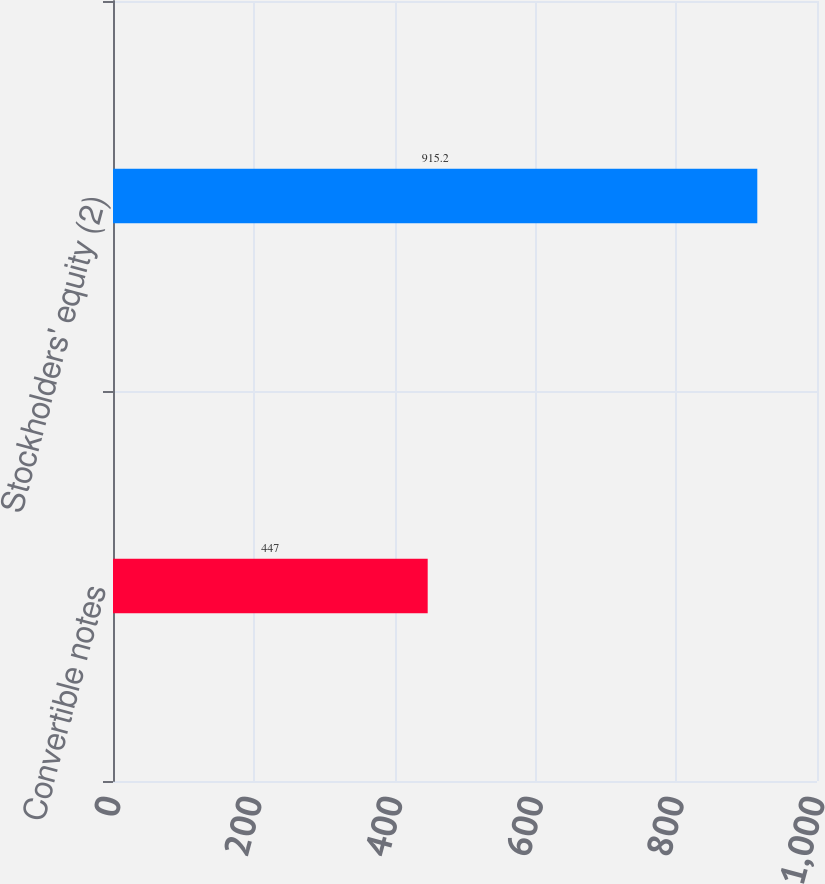<chart> <loc_0><loc_0><loc_500><loc_500><bar_chart><fcel>Convertible notes<fcel>Stockholders' equity (2)<nl><fcel>447<fcel>915.2<nl></chart> 